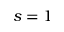Convert formula to latex. <formula><loc_0><loc_0><loc_500><loc_500>s = 1</formula> 